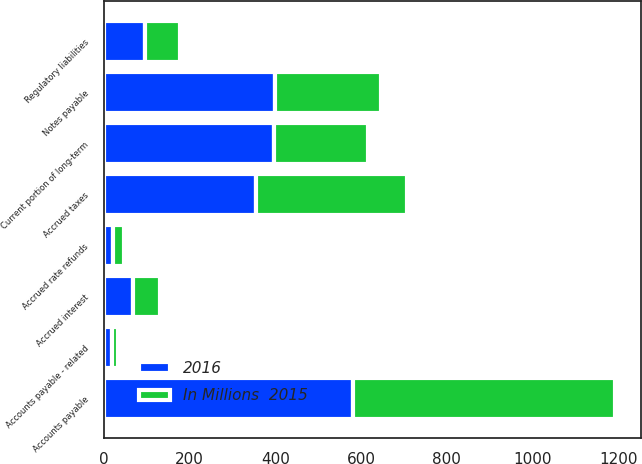<chart> <loc_0><loc_0><loc_500><loc_500><stacked_bar_chart><ecel><fcel>Current portion of long-term<fcel>Notes payable<fcel>Accounts payable<fcel>Accounts payable - related<fcel>Accrued rate refunds<fcel>Accrued interest<fcel>Accrued taxes<fcel>Regulatory liabilities<nl><fcel>2016<fcel>397<fcel>398<fcel>580<fcel>18<fcel>21<fcel>67<fcel>354<fcel>95<nl><fcel>In Millions  2015<fcel>220<fcel>249<fcel>613<fcel>15<fcel>26<fcel>65<fcel>352<fcel>82<nl></chart> 